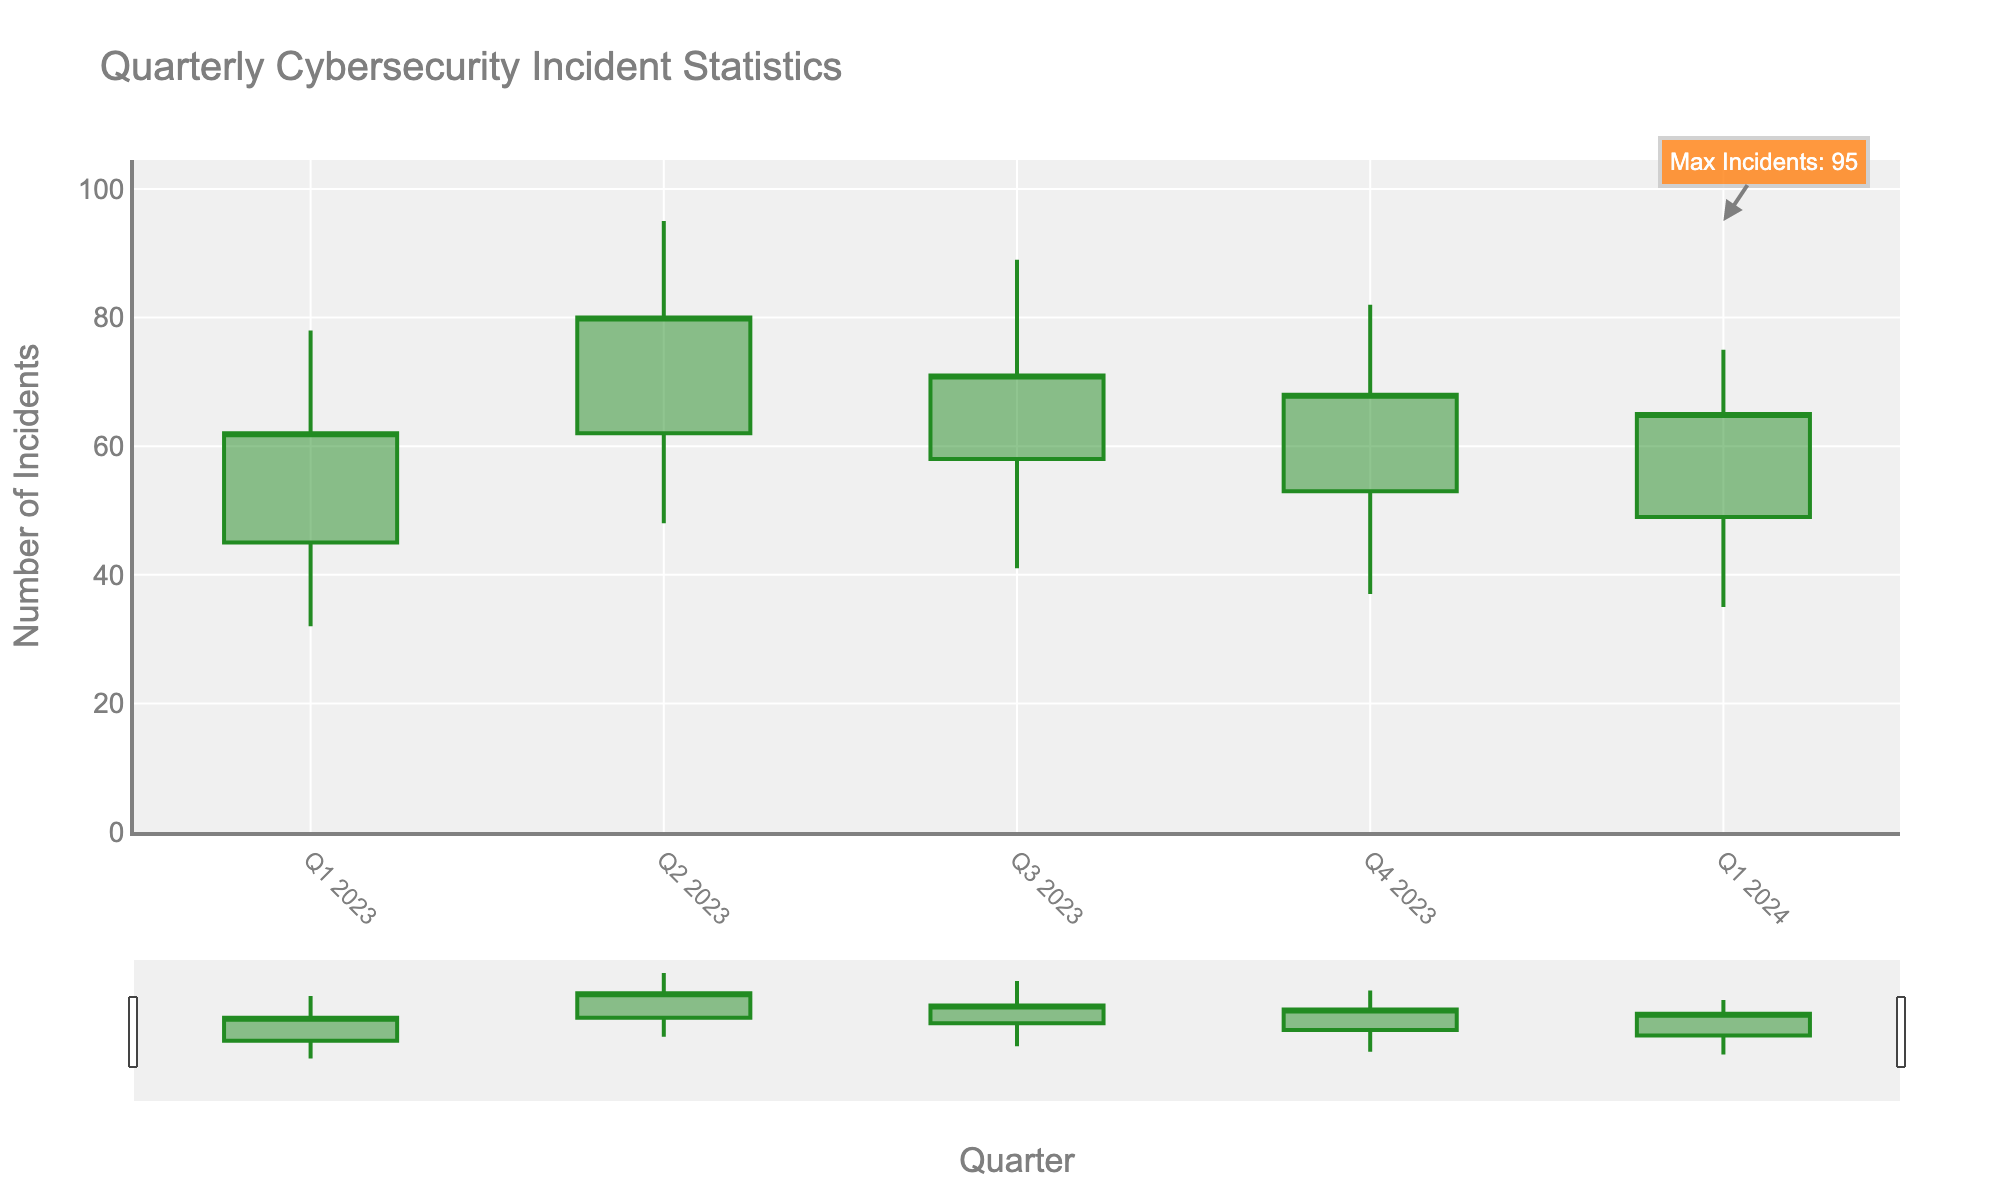What is the title of the figure? The title of the figure is located at the top and it allows us to understand the main subject of the data being visualized. The title in this case is "Quarterly Cybersecurity Incident Statistics", which gives an overview of what the chart is about.
Answer: Quarterly Cybersecurity Incident Statistics What information is on the y-axis? The y-axis of the figure represents the number of incidents, as indicated by the label "Number of Incidents". This allows us to quantify the values represented by the OHLC bars.
Answer: Number of Incidents How many quarters of data are presented in the figure? The x-axis has labels indicating the quarters, and by counting them, we can see that there are five quarters (Q1 2023, Q2 2023, Q3 2023, Q4 2023, Q1 2024) on the figure.
Answer: 5 quarters Which quarter had the highest number of high incidents? By looking at the peaks of the bars representing the high incidents, which are the top points of each candlestick bar, we find that Q2 2023 had the highest peak, indicating the highest number of high incidents at 95.
Answer: Q2 2023 What is the average severity of incidents in Q2 2023? The average severity of incidents for each quarter is usually found in the data label. For Q2 2023, the figure or data shows that the average severity of incidents is 3.7.
Answer: 3.7 In which quarter did the mean resolution time drop compared to the previous quarter? By inspecting the mean resolution time and comparing each quarter, the mean resolution time dropped in Q3 2023 compared to Q2 2023 and again in Q1 2024 compared to Q4 2023. But the first drop is noticed between Q2 2023 (22.3 days) and Q3 2023 (20.1 days).
Answer: Q3 2023 What is the difference between the highest and lowest incidents in Q3 2023? The highest value in Q3 2023 is 89 (HighIncidents) and the lowest value is 41 (LowIncidents). The difference between them is calculated as 89 - 41 = 48.
Answer: 48 Which quarter had fewer closed incidents, Q4 2023, or Q1 2024? We compare the closed incidents for both quarters. Q4 2023 had 68 closed incidents, and Q1 2024 had 65. Since 65 is fewer than 68, Q1 2024 had fewer closed incidents.
Answer: Q1 2024 Which color represents increasing incidents in the chart? The color representing increasing incidents is usually specified in the figure's trace colors. The increasing line color in this figure is '#228B22', which corresponds to forest green and visually can be checked as green color.
Answer: Green What was the value for the max number of incidents, and in which quarter did it occur? The annotation present in the figure indicates "Max Incidents: 95", which corresponds to the highest point in Q2 2023. This directly points out the value and the specific quarter.
Answer: 95 in Q2 2023 